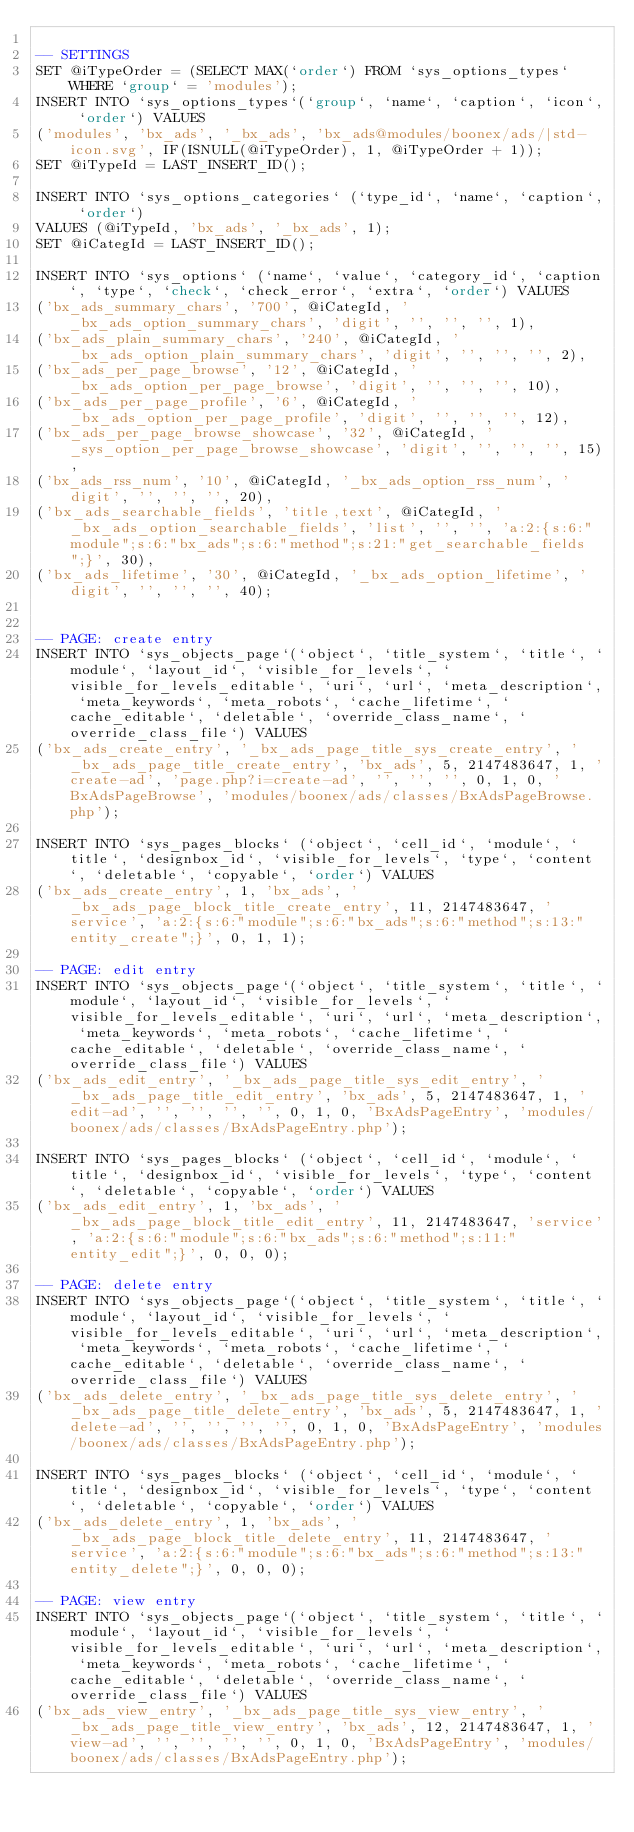Convert code to text. <code><loc_0><loc_0><loc_500><loc_500><_SQL_>
-- SETTINGS
SET @iTypeOrder = (SELECT MAX(`order`) FROM `sys_options_types` WHERE `group` = 'modules');
INSERT INTO `sys_options_types`(`group`, `name`, `caption`, `icon`, `order`) VALUES 
('modules', 'bx_ads', '_bx_ads', 'bx_ads@modules/boonex/ads/|std-icon.svg', IF(ISNULL(@iTypeOrder), 1, @iTypeOrder + 1));
SET @iTypeId = LAST_INSERT_ID();

INSERT INTO `sys_options_categories` (`type_id`, `name`, `caption`, `order`)
VALUES (@iTypeId, 'bx_ads', '_bx_ads', 1);
SET @iCategId = LAST_INSERT_ID();

INSERT INTO `sys_options` (`name`, `value`, `category_id`, `caption`, `type`, `check`, `check_error`, `extra`, `order`) VALUES
('bx_ads_summary_chars', '700', @iCategId, '_bx_ads_option_summary_chars', 'digit', '', '', '', 1),
('bx_ads_plain_summary_chars', '240', @iCategId, '_bx_ads_option_plain_summary_chars', 'digit', '', '', '', 2),
('bx_ads_per_page_browse', '12', @iCategId, '_bx_ads_option_per_page_browse', 'digit', '', '', '', 10),
('bx_ads_per_page_profile', '6', @iCategId, '_bx_ads_option_per_page_profile', 'digit', '', '', '', 12),
('bx_ads_per_page_browse_showcase', '32', @iCategId, '_sys_option_per_page_browse_showcase', 'digit', '', '', '', 15),
('bx_ads_rss_num', '10', @iCategId, '_bx_ads_option_rss_num', 'digit', '', '', '', 20),
('bx_ads_searchable_fields', 'title,text', @iCategId, '_bx_ads_option_searchable_fields', 'list', '', '', 'a:2:{s:6:"module";s:6:"bx_ads";s:6:"method";s:21:"get_searchable_fields";}', 30),
('bx_ads_lifetime', '30', @iCategId, '_bx_ads_option_lifetime', 'digit', '', '', '', 40);


-- PAGE: create entry
INSERT INTO `sys_objects_page`(`object`, `title_system`, `title`, `module`, `layout_id`, `visible_for_levels`, `visible_for_levels_editable`, `uri`, `url`, `meta_description`, `meta_keywords`, `meta_robots`, `cache_lifetime`, `cache_editable`, `deletable`, `override_class_name`, `override_class_file`) VALUES 
('bx_ads_create_entry', '_bx_ads_page_title_sys_create_entry', '_bx_ads_page_title_create_entry', 'bx_ads', 5, 2147483647, 1, 'create-ad', 'page.php?i=create-ad', '', '', '', 0, 1, 0, 'BxAdsPageBrowse', 'modules/boonex/ads/classes/BxAdsPageBrowse.php');

INSERT INTO `sys_pages_blocks` (`object`, `cell_id`, `module`, `title`, `designbox_id`, `visible_for_levels`, `type`, `content`, `deletable`, `copyable`, `order`) VALUES
('bx_ads_create_entry', 1, 'bx_ads', '_bx_ads_page_block_title_create_entry', 11, 2147483647, 'service', 'a:2:{s:6:"module";s:6:"bx_ads";s:6:"method";s:13:"entity_create";}', 0, 1, 1);

-- PAGE: edit entry
INSERT INTO `sys_objects_page`(`object`, `title_system`, `title`, `module`, `layout_id`, `visible_for_levels`, `visible_for_levels_editable`, `uri`, `url`, `meta_description`, `meta_keywords`, `meta_robots`, `cache_lifetime`, `cache_editable`, `deletable`, `override_class_name`, `override_class_file`) VALUES 
('bx_ads_edit_entry', '_bx_ads_page_title_sys_edit_entry', '_bx_ads_page_title_edit_entry', 'bx_ads', 5, 2147483647, 1, 'edit-ad', '', '', '', '', 0, 1, 0, 'BxAdsPageEntry', 'modules/boonex/ads/classes/BxAdsPageEntry.php');

INSERT INTO `sys_pages_blocks` (`object`, `cell_id`, `module`, `title`, `designbox_id`, `visible_for_levels`, `type`, `content`, `deletable`, `copyable`, `order`) VALUES
('bx_ads_edit_entry', 1, 'bx_ads', '_bx_ads_page_block_title_edit_entry', 11, 2147483647, 'service', 'a:2:{s:6:"module";s:6:"bx_ads";s:6:"method";s:11:"entity_edit";}', 0, 0, 0);

-- PAGE: delete entry
INSERT INTO `sys_objects_page`(`object`, `title_system`, `title`, `module`, `layout_id`, `visible_for_levels`, `visible_for_levels_editable`, `uri`, `url`, `meta_description`, `meta_keywords`, `meta_robots`, `cache_lifetime`, `cache_editable`, `deletable`, `override_class_name`, `override_class_file`) VALUES 
('bx_ads_delete_entry', '_bx_ads_page_title_sys_delete_entry', '_bx_ads_page_title_delete_entry', 'bx_ads', 5, 2147483647, 1, 'delete-ad', '', '', '', '', 0, 1, 0, 'BxAdsPageEntry', 'modules/boonex/ads/classes/BxAdsPageEntry.php');

INSERT INTO `sys_pages_blocks` (`object`, `cell_id`, `module`, `title`, `designbox_id`, `visible_for_levels`, `type`, `content`, `deletable`, `copyable`, `order`) VALUES
('bx_ads_delete_entry', 1, 'bx_ads', '_bx_ads_page_block_title_delete_entry', 11, 2147483647, 'service', 'a:2:{s:6:"module";s:6:"bx_ads";s:6:"method";s:13:"entity_delete";}', 0, 0, 0);

-- PAGE: view entry
INSERT INTO `sys_objects_page`(`object`, `title_system`, `title`, `module`, `layout_id`, `visible_for_levels`, `visible_for_levels_editable`, `uri`, `url`, `meta_description`, `meta_keywords`, `meta_robots`, `cache_lifetime`, `cache_editable`, `deletable`, `override_class_name`, `override_class_file`) VALUES 
('bx_ads_view_entry', '_bx_ads_page_title_sys_view_entry', '_bx_ads_page_title_view_entry', 'bx_ads', 12, 2147483647, 1, 'view-ad', '', '', '', '', 0, 1, 0, 'BxAdsPageEntry', 'modules/boonex/ads/classes/BxAdsPageEntry.php');
</code> 